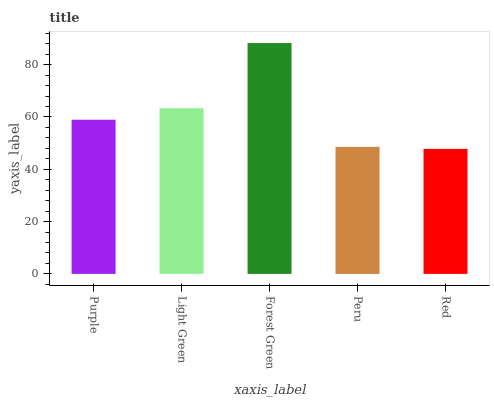Is Red the minimum?
Answer yes or no. Yes. Is Forest Green the maximum?
Answer yes or no. Yes. Is Light Green the minimum?
Answer yes or no. No. Is Light Green the maximum?
Answer yes or no. No. Is Light Green greater than Purple?
Answer yes or no. Yes. Is Purple less than Light Green?
Answer yes or no. Yes. Is Purple greater than Light Green?
Answer yes or no. No. Is Light Green less than Purple?
Answer yes or no. No. Is Purple the high median?
Answer yes or no. Yes. Is Purple the low median?
Answer yes or no. Yes. Is Peru the high median?
Answer yes or no. No. Is Red the low median?
Answer yes or no. No. 